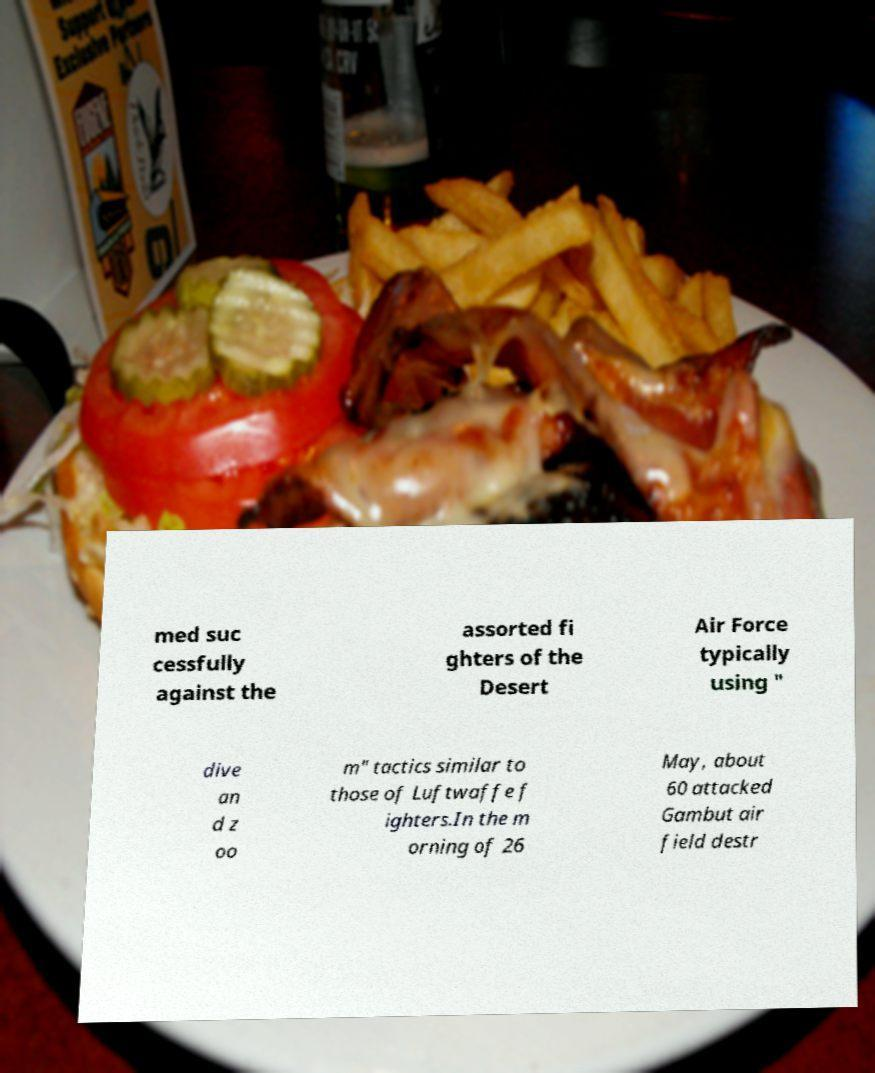What messages or text are displayed in this image? I need them in a readable, typed format. med suc cessfully against the assorted fi ghters of the Desert Air Force typically using " dive an d z oo m" tactics similar to those of Luftwaffe f ighters.In the m orning of 26 May, about 60 attacked Gambut air field destr 